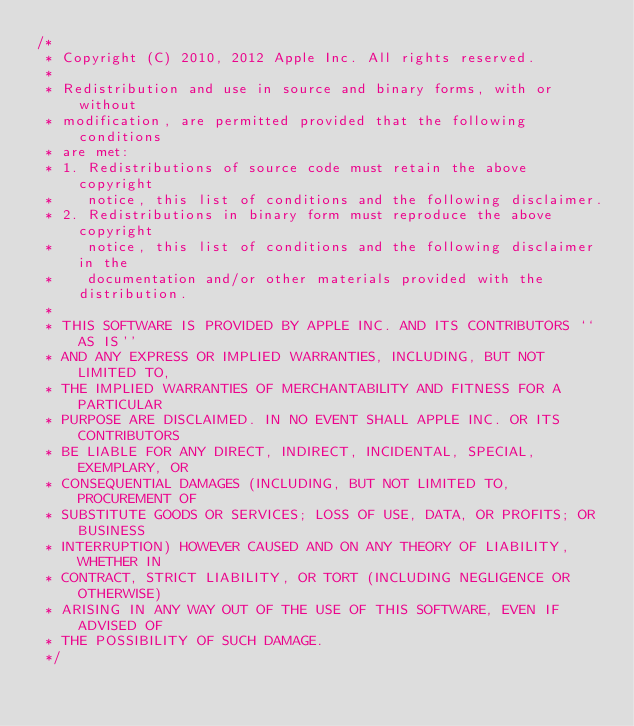<code> <loc_0><loc_0><loc_500><loc_500><_ObjectiveC_>/*
 * Copyright (C) 2010, 2012 Apple Inc. All rights reserved.
 *
 * Redistribution and use in source and binary forms, with or without
 * modification, are permitted provided that the following conditions
 * are met:
 * 1. Redistributions of source code must retain the above copyright
 *    notice, this list of conditions and the following disclaimer.
 * 2. Redistributions in binary form must reproduce the above copyright
 *    notice, this list of conditions and the following disclaimer in the
 *    documentation and/or other materials provided with the distribution.
 *
 * THIS SOFTWARE IS PROVIDED BY APPLE INC. AND ITS CONTRIBUTORS ``AS IS''
 * AND ANY EXPRESS OR IMPLIED WARRANTIES, INCLUDING, BUT NOT LIMITED TO,
 * THE IMPLIED WARRANTIES OF MERCHANTABILITY AND FITNESS FOR A PARTICULAR
 * PURPOSE ARE DISCLAIMED. IN NO EVENT SHALL APPLE INC. OR ITS CONTRIBUTORS
 * BE LIABLE FOR ANY DIRECT, INDIRECT, INCIDENTAL, SPECIAL, EXEMPLARY, OR
 * CONSEQUENTIAL DAMAGES (INCLUDING, BUT NOT LIMITED TO, PROCUREMENT OF
 * SUBSTITUTE GOODS OR SERVICES; LOSS OF USE, DATA, OR PROFITS; OR BUSINESS
 * INTERRUPTION) HOWEVER CAUSED AND ON ANY THEORY OF LIABILITY, WHETHER IN
 * CONTRACT, STRICT LIABILITY, OR TORT (INCLUDING NEGLIGENCE OR OTHERWISE)
 * ARISING IN ANY WAY OUT OF THE USE OF THIS SOFTWARE, EVEN IF ADVISED OF
 * THE POSSIBILITY OF SUCH DAMAGE.
 */
</code> 